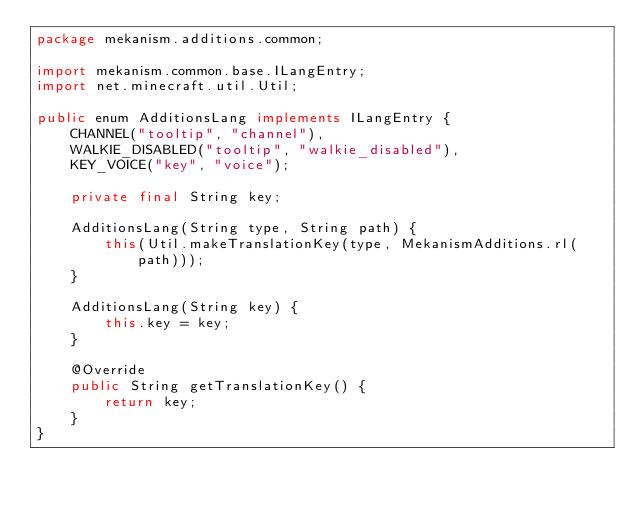Convert code to text. <code><loc_0><loc_0><loc_500><loc_500><_Java_>package mekanism.additions.common;

import mekanism.common.base.ILangEntry;
import net.minecraft.util.Util;

public enum AdditionsLang implements ILangEntry {
    CHANNEL("tooltip", "channel"),
    WALKIE_DISABLED("tooltip", "walkie_disabled"),
    KEY_VOICE("key", "voice");

    private final String key;

    AdditionsLang(String type, String path) {
        this(Util.makeTranslationKey(type, MekanismAdditions.rl(path)));
    }

    AdditionsLang(String key) {
        this.key = key;
    }

    @Override
    public String getTranslationKey() {
        return key;
    }
}</code> 